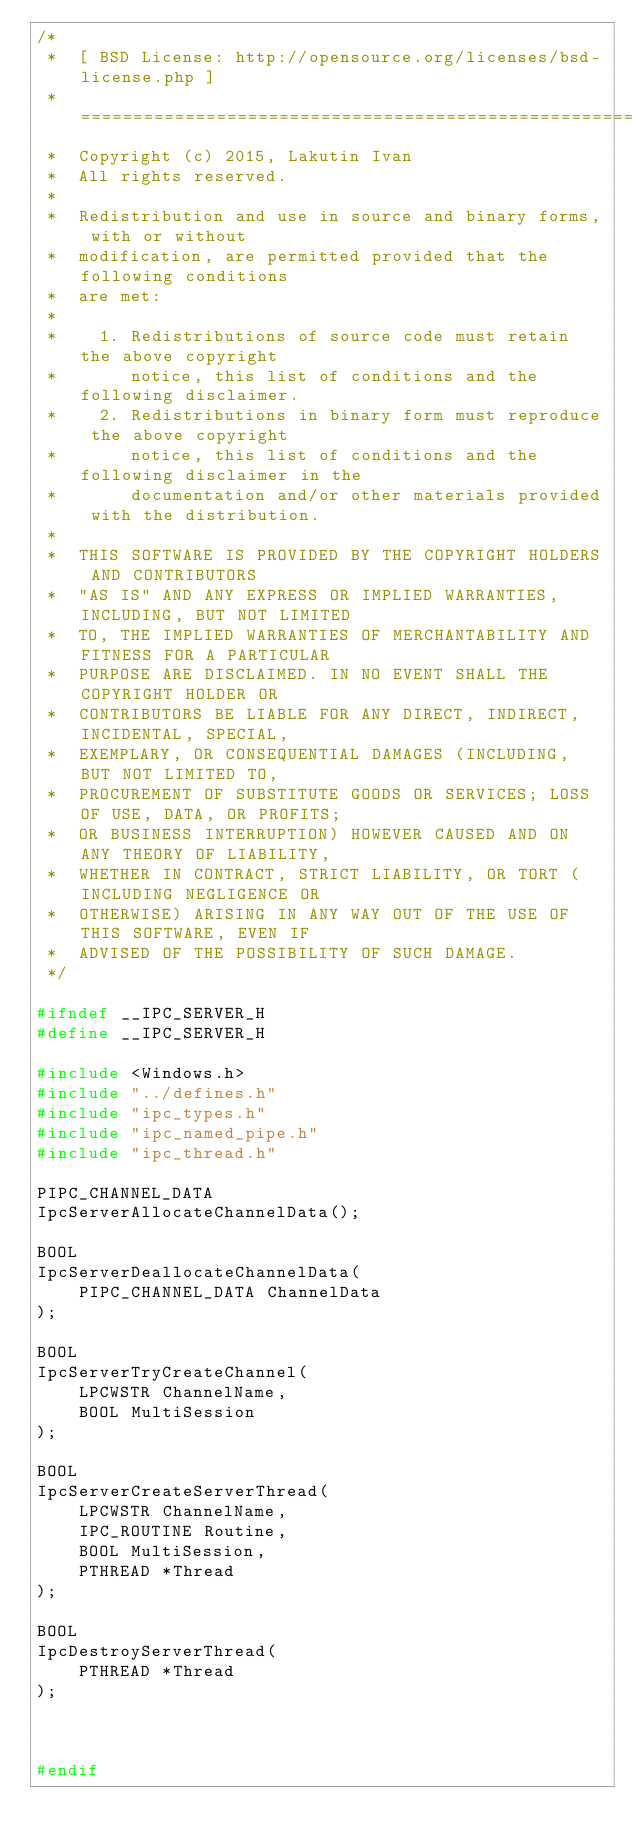Convert code to text. <code><loc_0><loc_0><loc_500><loc_500><_C_>/*
 *  [ BSD License: http://opensource.org/licenses/bsd-license.php ]
 *  ===========================================================================
 *  Copyright (c) 2015, Lakutin Ivan
 *  All rights reserved.
 *
 *  Redistribution and use in source and binary forms, with or without
 *  modification, are permitted provided that the following conditions
 *  are met:
 *
 *    1. Redistributions of source code must retain the above copyright
 *       notice, this list of conditions and the following disclaimer.
 *    2. Redistributions in binary form must reproduce the above copyright
 *       notice, this list of conditions and the following disclaimer in the
 *       documentation and/or other materials provided with the distribution.
 *
 *  THIS SOFTWARE IS PROVIDED BY THE COPYRIGHT HOLDERS AND CONTRIBUTORS
 *  "AS IS" AND ANY EXPRESS OR IMPLIED WARRANTIES, INCLUDING, BUT NOT LIMITED
 *  TO, THE IMPLIED WARRANTIES OF MERCHANTABILITY AND FITNESS FOR A PARTICULAR
 *  PURPOSE ARE DISCLAIMED. IN NO EVENT SHALL THE COPYRIGHT HOLDER OR
 *  CONTRIBUTORS BE LIABLE FOR ANY DIRECT, INDIRECT, INCIDENTAL, SPECIAL,
 *  EXEMPLARY, OR CONSEQUENTIAL DAMAGES (INCLUDING, BUT NOT LIMITED TO,
 *  PROCUREMENT OF SUBSTITUTE GOODS OR SERVICES; LOSS OF USE, DATA, OR PROFITS;
 *  OR BUSINESS INTERRUPTION) HOWEVER CAUSED AND ON ANY THEORY OF LIABILITY,
 *  WHETHER IN CONTRACT, STRICT LIABILITY, OR TORT (INCLUDING NEGLIGENCE OR
 *  OTHERWISE) ARISING IN ANY WAY OUT OF THE USE OF THIS SOFTWARE, EVEN IF
 *  ADVISED OF THE POSSIBILITY OF SUCH DAMAGE.
 */

#ifndef __IPC_SERVER_H
#define __IPC_SERVER_H

#include <Windows.h>
#include "../defines.h"
#include "ipc_types.h"
#include "ipc_named_pipe.h"
#include "ipc_thread.h"

PIPC_CHANNEL_DATA
IpcServerAllocateChannelData();

BOOL
IpcServerDeallocateChannelData(
    PIPC_CHANNEL_DATA ChannelData
);

BOOL
IpcServerTryCreateChannel(
    LPCWSTR ChannelName,
    BOOL MultiSession
);

BOOL
IpcServerCreateServerThread(
    LPCWSTR ChannelName,
    IPC_ROUTINE Routine,
    BOOL MultiSession,
    PTHREAD *Thread
);

BOOL
IpcDestroyServerThread(
    PTHREAD *Thread
);



#endif
</code> 